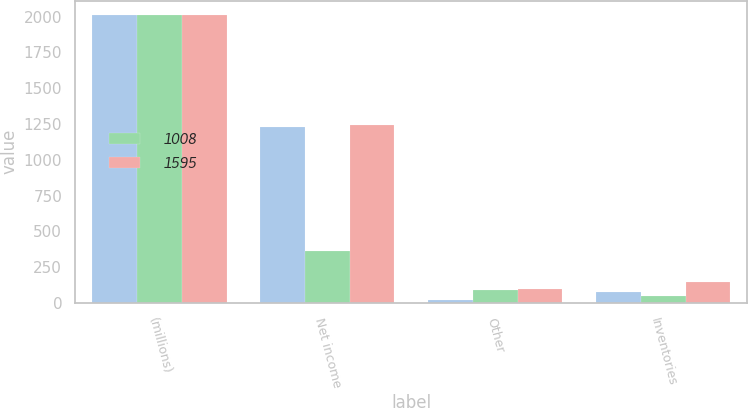<chart> <loc_0><loc_0><loc_500><loc_500><stacked_bar_chart><ecel><fcel>(millions)<fcel>Net income<fcel>Other<fcel>Inventories<nl><fcel>nan<fcel>2011<fcel>1229<fcel>22<fcel>76<nl><fcel>1008<fcel>2011<fcel>365<fcel>93<fcel>49<nl><fcel>1595<fcel>2010<fcel>1240<fcel>97<fcel>146<nl></chart> 